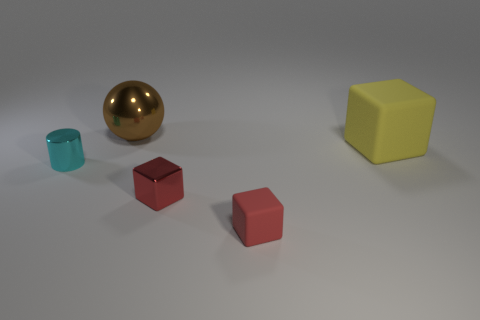Add 5 metallic things. How many objects exist? 10 Subtract all cylinders. How many objects are left? 4 Subtract 0 green balls. How many objects are left? 5 Subtract all small red matte blocks. Subtract all yellow objects. How many objects are left? 3 Add 3 balls. How many balls are left? 4 Add 2 brown things. How many brown things exist? 3 